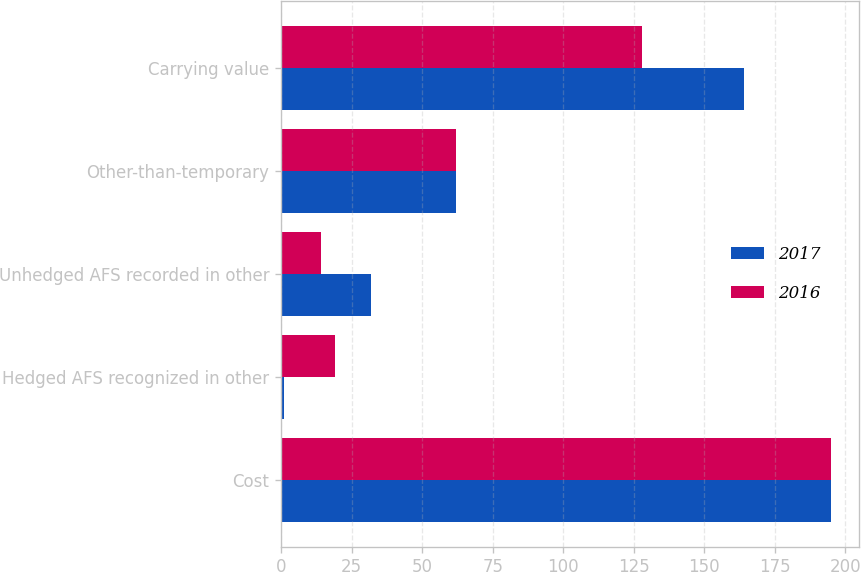Convert chart. <chart><loc_0><loc_0><loc_500><loc_500><stacked_bar_chart><ecel><fcel>Cost<fcel>Hedged AFS recognized in other<fcel>Unhedged AFS recorded in other<fcel>Other-than-temporary<fcel>Carrying value<nl><fcel>2017<fcel>195<fcel>1<fcel>32<fcel>62<fcel>164<nl><fcel>2016<fcel>195<fcel>19<fcel>14<fcel>62<fcel>128<nl></chart> 